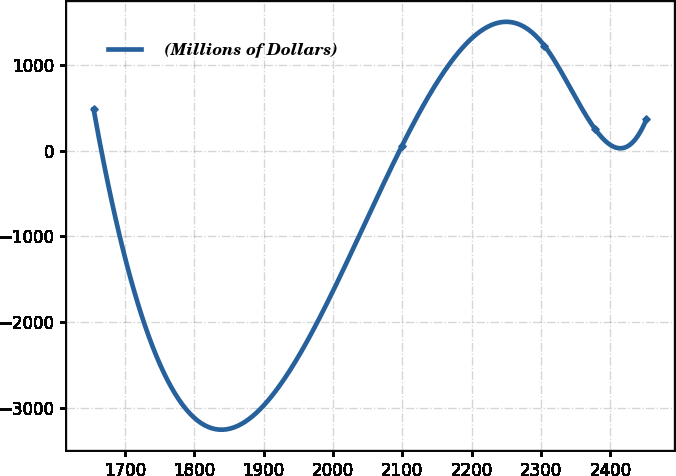Convert chart to OTSL. <chart><loc_0><loc_0><loc_500><loc_500><line_chart><ecel><fcel>(Millions of Dollars)<nl><fcel>1654.98<fcel>485.47<nl><fcel>2099.35<fcel>56.78<nl><fcel>2304.62<fcel>1231.29<nl><fcel>2378.23<fcel>250.57<nl><fcel>2451.84<fcel>368.02<nl></chart> 